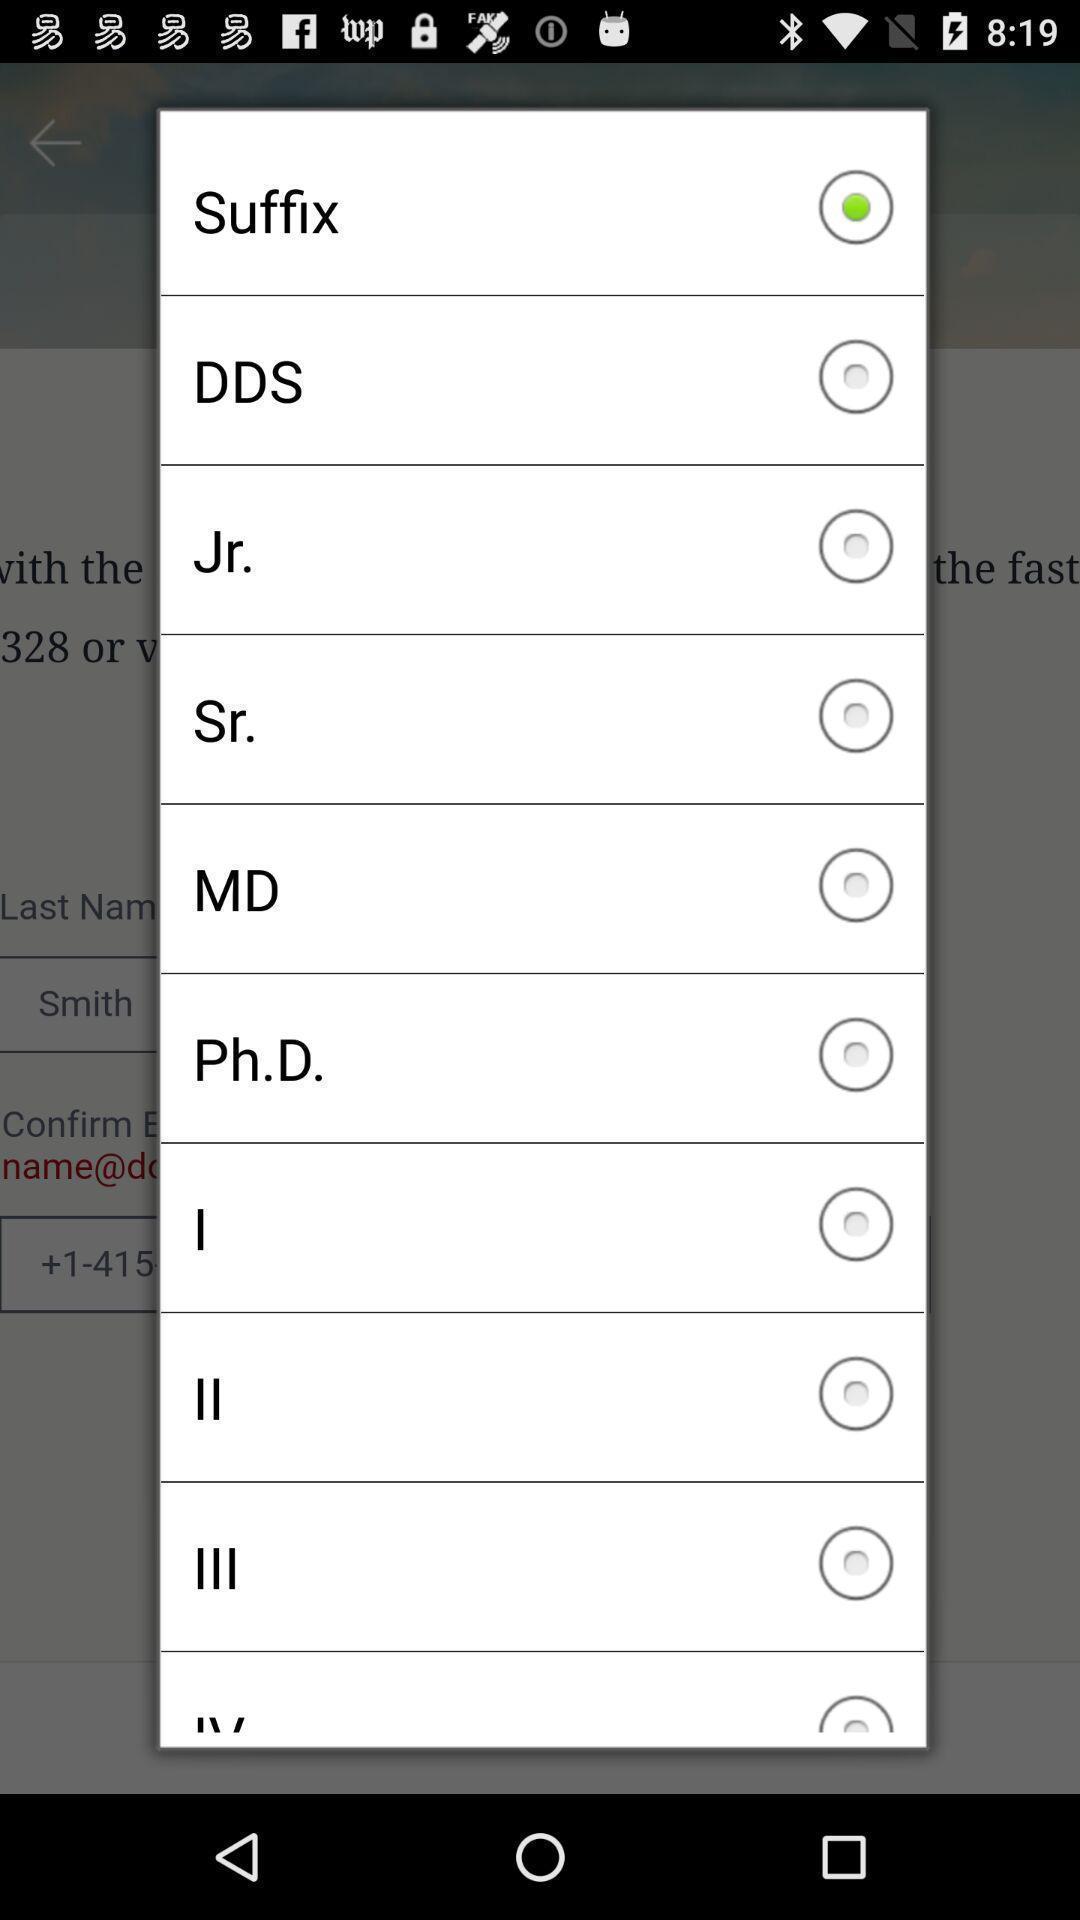Give me a summary of this screen capture. Pop-up with various options of suffix. 